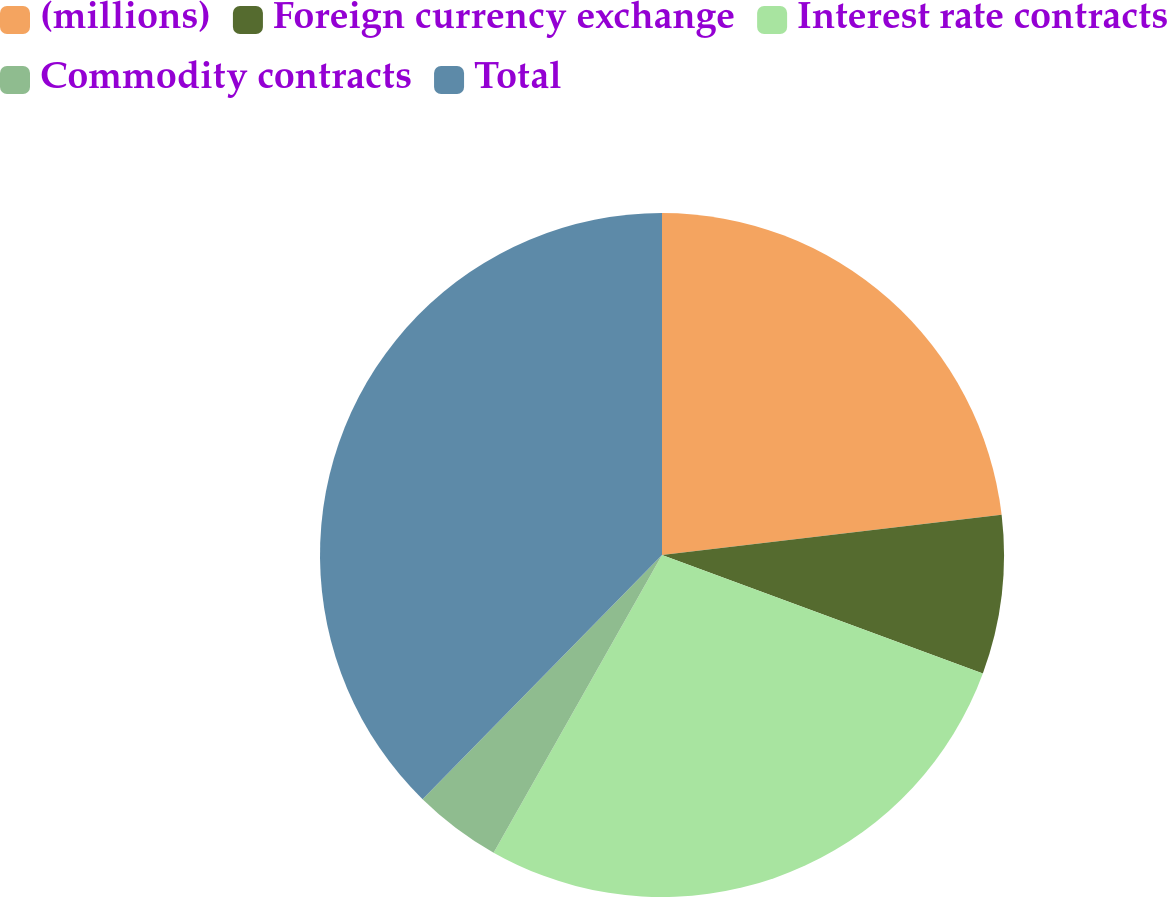Convert chart to OTSL. <chart><loc_0><loc_0><loc_500><loc_500><pie_chart><fcel>(millions)<fcel>Foreign currency exchange<fcel>Interest rate contracts<fcel>Commodity contracts<fcel>Total<nl><fcel>23.13%<fcel>7.5%<fcel>27.57%<fcel>4.15%<fcel>37.66%<nl></chart> 